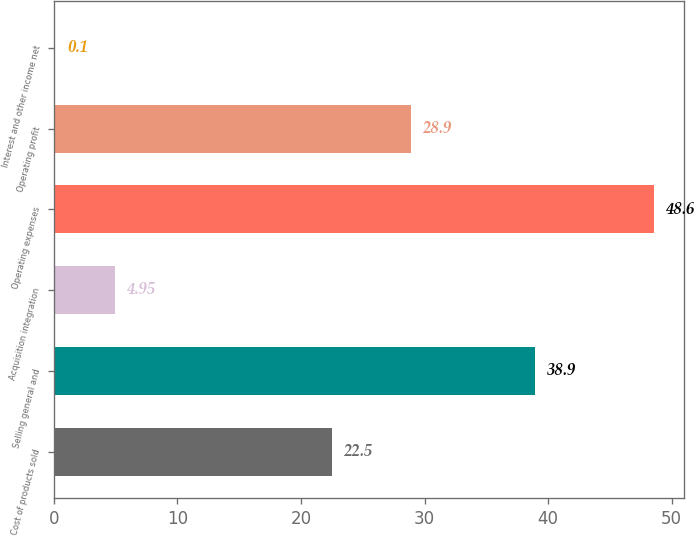<chart> <loc_0><loc_0><loc_500><loc_500><bar_chart><fcel>Cost of products sold<fcel>Selling general and<fcel>Acquisition integration<fcel>Operating expenses<fcel>Operating profit<fcel>Interest and other income net<nl><fcel>22.5<fcel>38.9<fcel>4.95<fcel>48.6<fcel>28.9<fcel>0.1<nl></chart> 